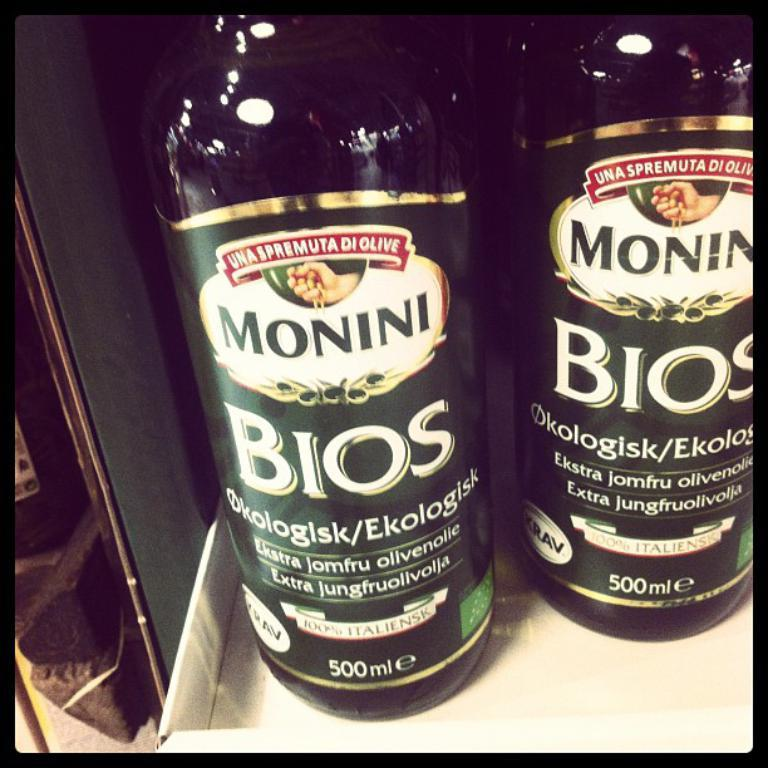<image>
Relay a brief, clear account of the picture shown. some bottles of Monini Bios 500 ML on a display shelf 